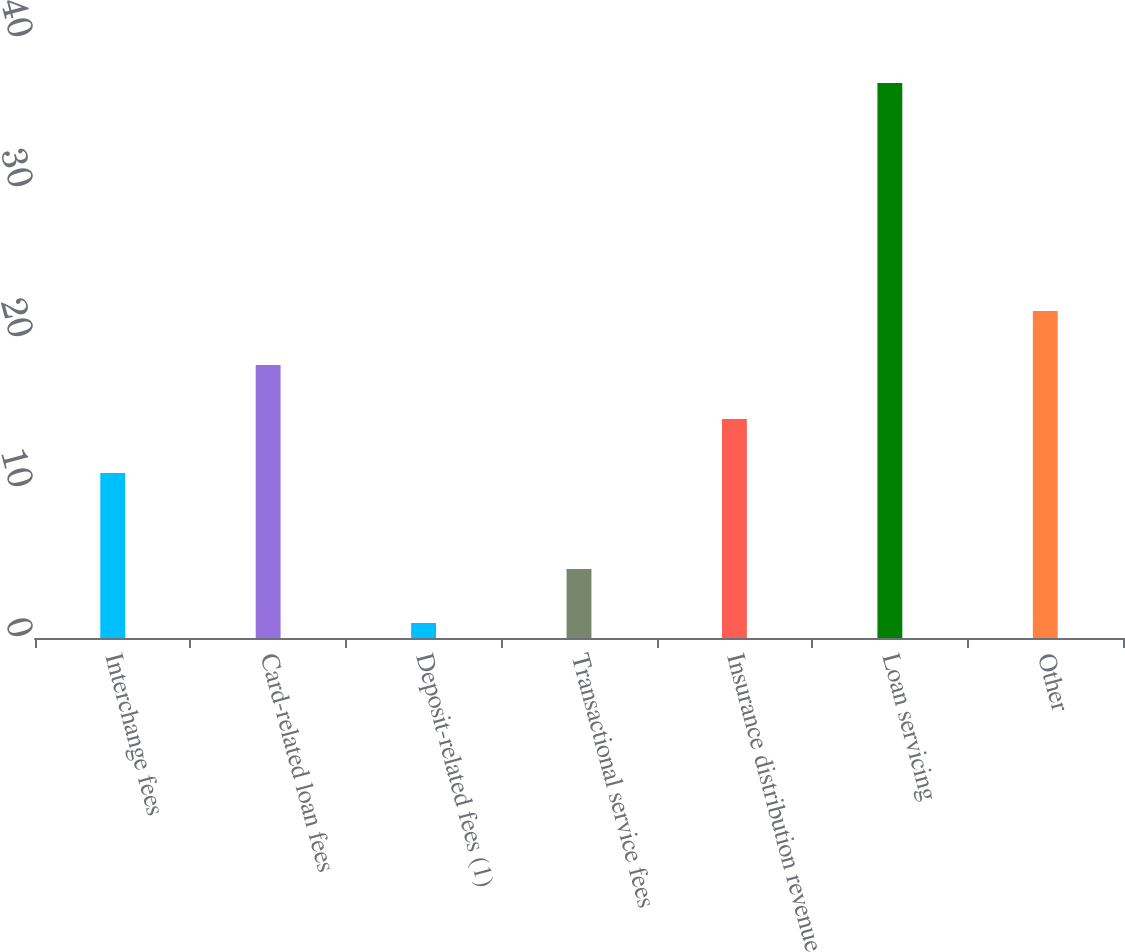Convert chart. <chart><loc_0><loc_0><loc_500><loc_500><bar_chart><fcel>Interchange fees<fcel>Card-related loan fees<fcel>Deposit-related fees (1)<fcel>Transactional service fees<fcel>Insurance distribution revenue<fcel>Loan servicing<fcel>Other<nl><fcel>11<fcel>18.2<fcel>1<fcel>4.6<fcel>14.6<fcel>37<fcel>21.8<nl></chart> 